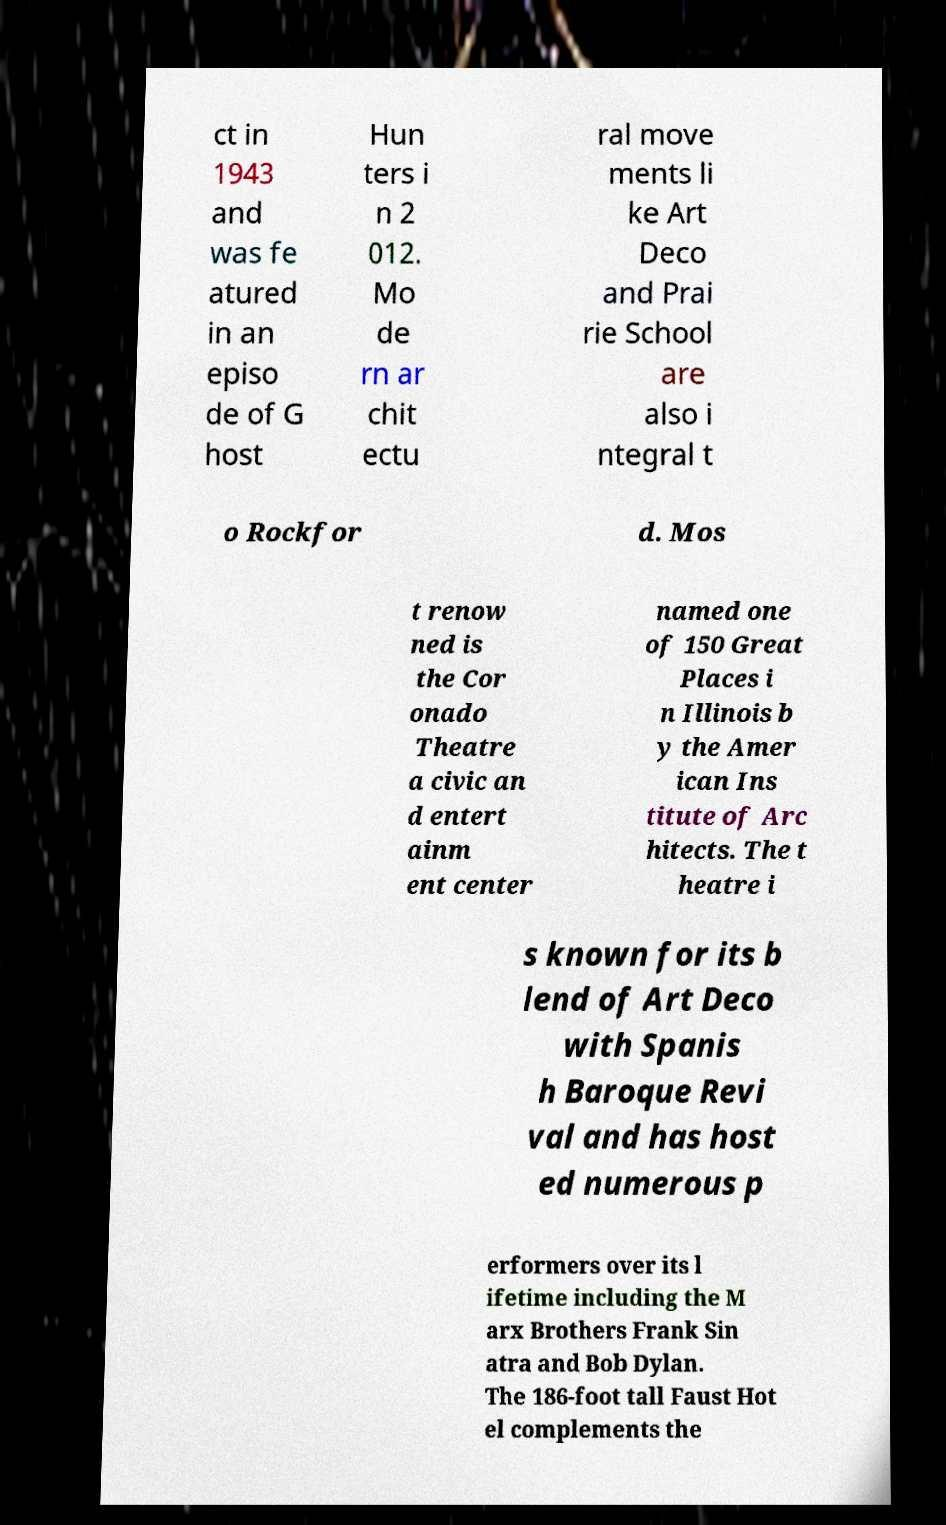Please identify and transcribe the text found in this image. ct in 1943 and was fe atured in an episo de of G host Hun ters i n 2 012. Mo de rn ar chit ectu ral move ments li ke Art Deco and Prai rie School are also i ntegral t o Rockfor d. Mos t renow ned is the Cor onado Theatre a civic an d entert ainm ent center named one of 150 Great Places i n Illinois b y the Amer ican Ins titute of Arc hitects. The t heatre i s known for its b lend of Art Deco with Spanis h Baroque Revi val and has host ed numerous p erformers over its l ifetime including the M arx Brothers Frank Sin atra and Bob Dylan. The 186-foot tall Faust Hot el complements the 